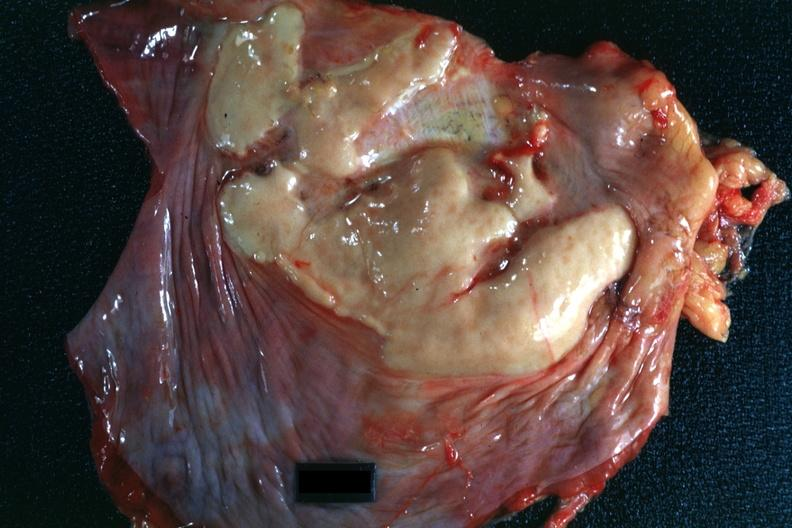what is present?
Answer the question using a single word or phrase. Soft tissue 